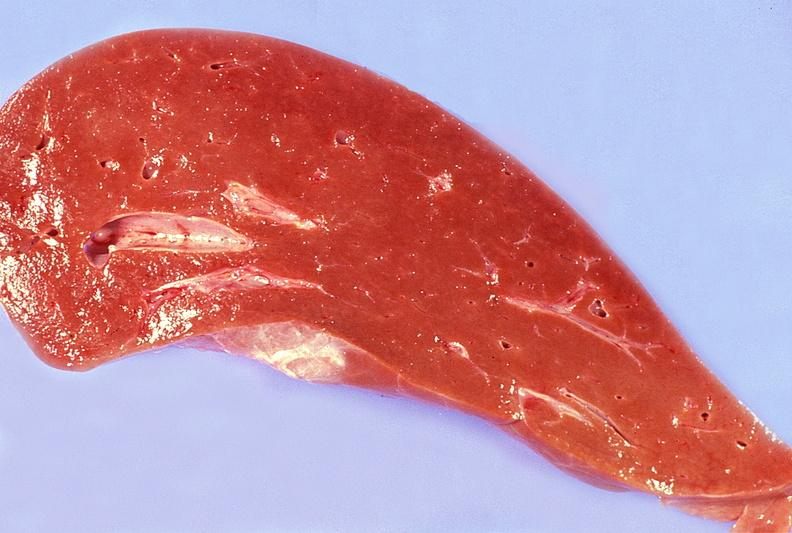s yo present?
Answer the question using a single word or phrase. No 